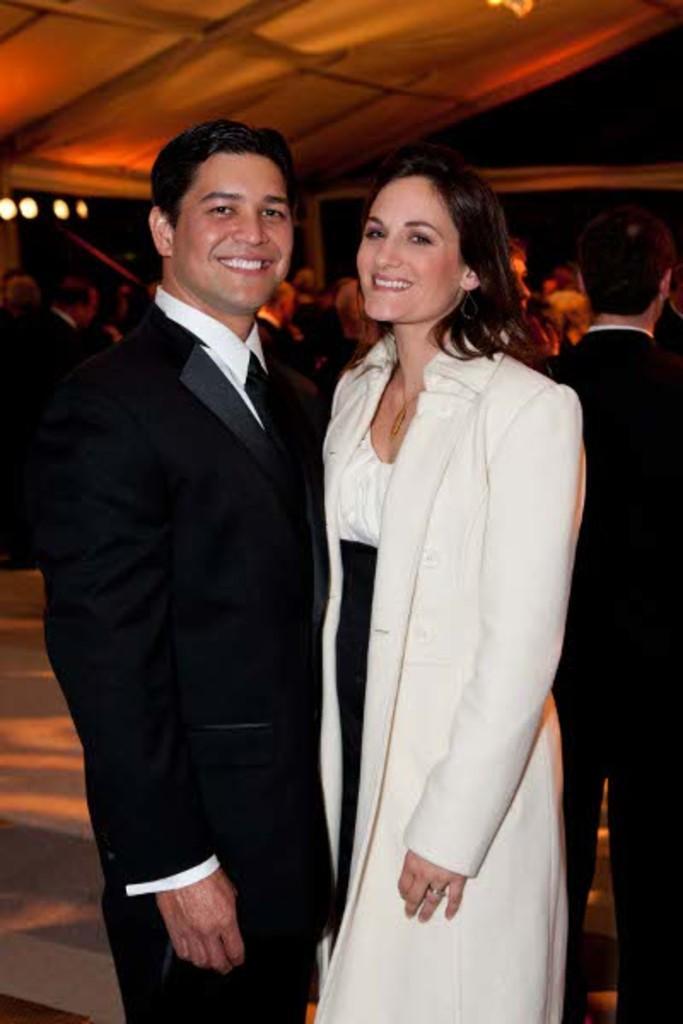In one or two sentences, can you explain what this image depicts? In this image we can see a man and woman is standing. Man is wearing black color suit and the woman is wearing white color coat. behind so many people are present. 